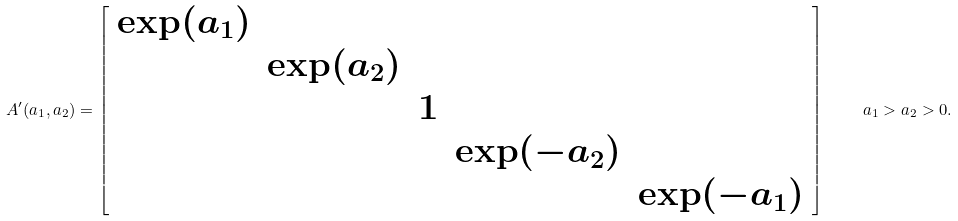Convert formula to latex. <formula><loc_0><loc_0><loc_500><loc_500>A ^ { \prime } ( a _ { 1 } , a _ { 2 } ) = \left [ \begin{array} { c c c c c } \exp ( a _ { 1 } ) & & & & \\ & \exp ( a _ { 2 } ) & & & \\ & & 1 & & \\ & & & \exp ( - a _ { 2 } ) & \\ & & & & \exp ( - a _ { 1 } ) \end{array} \right ] \quad a _ { 1 } > a _ { 2 } > 0 .</formula> 